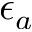Convert formula to latex. <formula><loc_0><loc_0><loc_500><loc_500>\epsilon _ { a }</formula> 